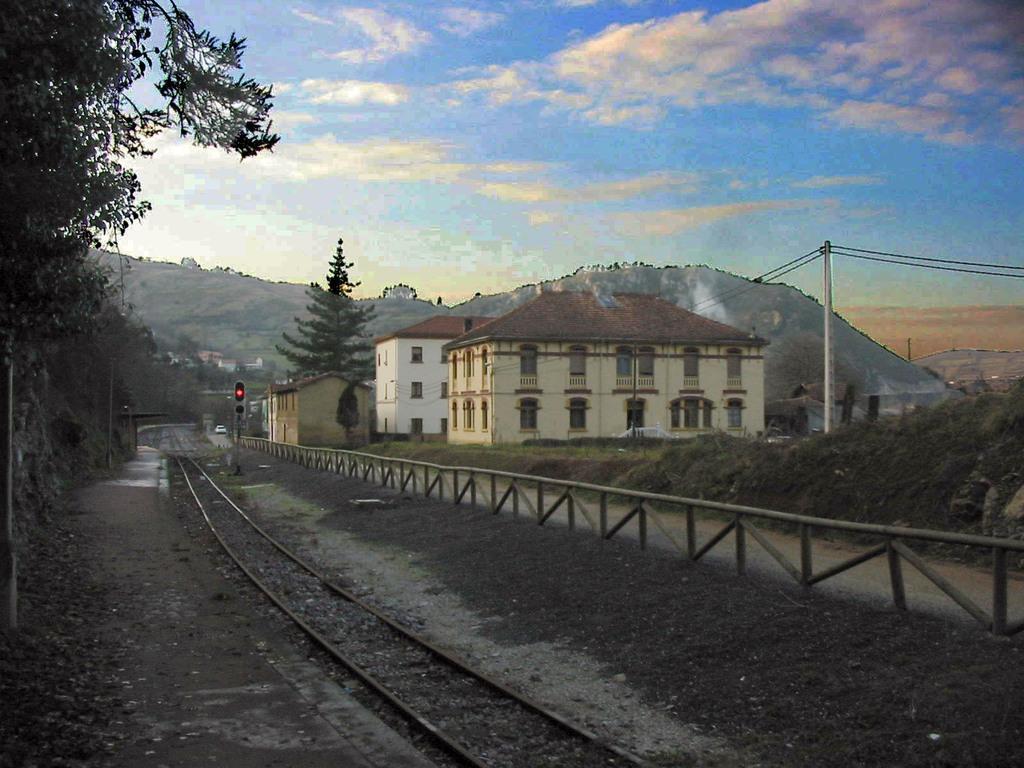Could you give a brief overview of what you see in this image? In this picture we can see few trees, tracks, fence and signal lights, in the background we can find few buildings, pole, hills and clouds. 